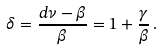Convert formula to latex. <formula><loc_0><loc_0><loc_500><loc_500>\delta = \frac { d \nu - \beta } { \beta } = 1 + \frac { \gamma } { \beta } \, .</formula> 